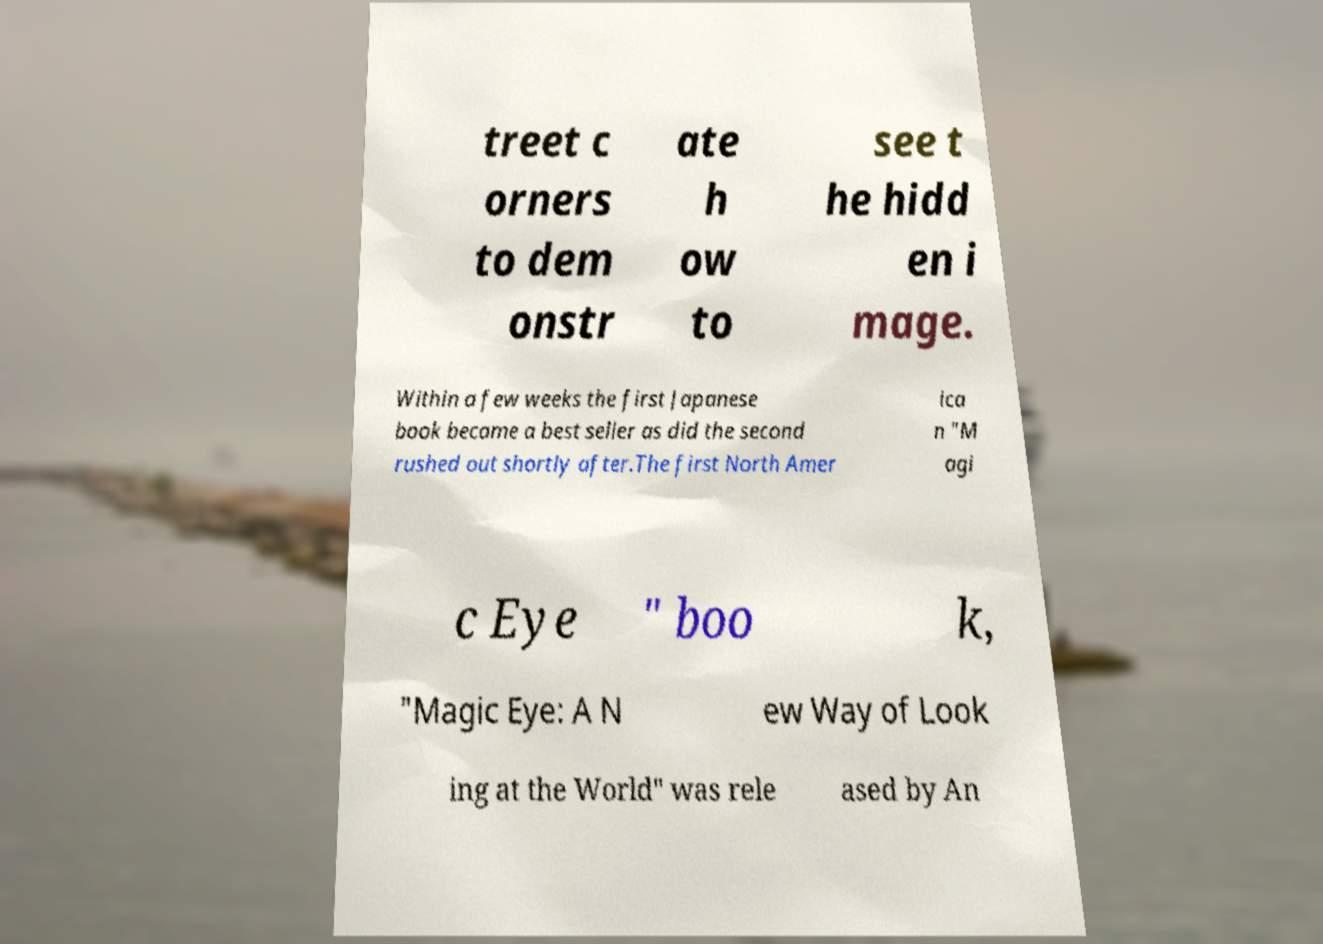Please identify and transcribe the text found in this image. treet c orners to dem onstr ate h ow to see t he hidd en i mage. Within a few weeks the first Japanese book became a best seller as did the second rushed out shortly after.The first North Amer ica n "M agi c Eye " boo k, "Magic Eye: A N ew Way of Look ing at the World" was rele ased by An 